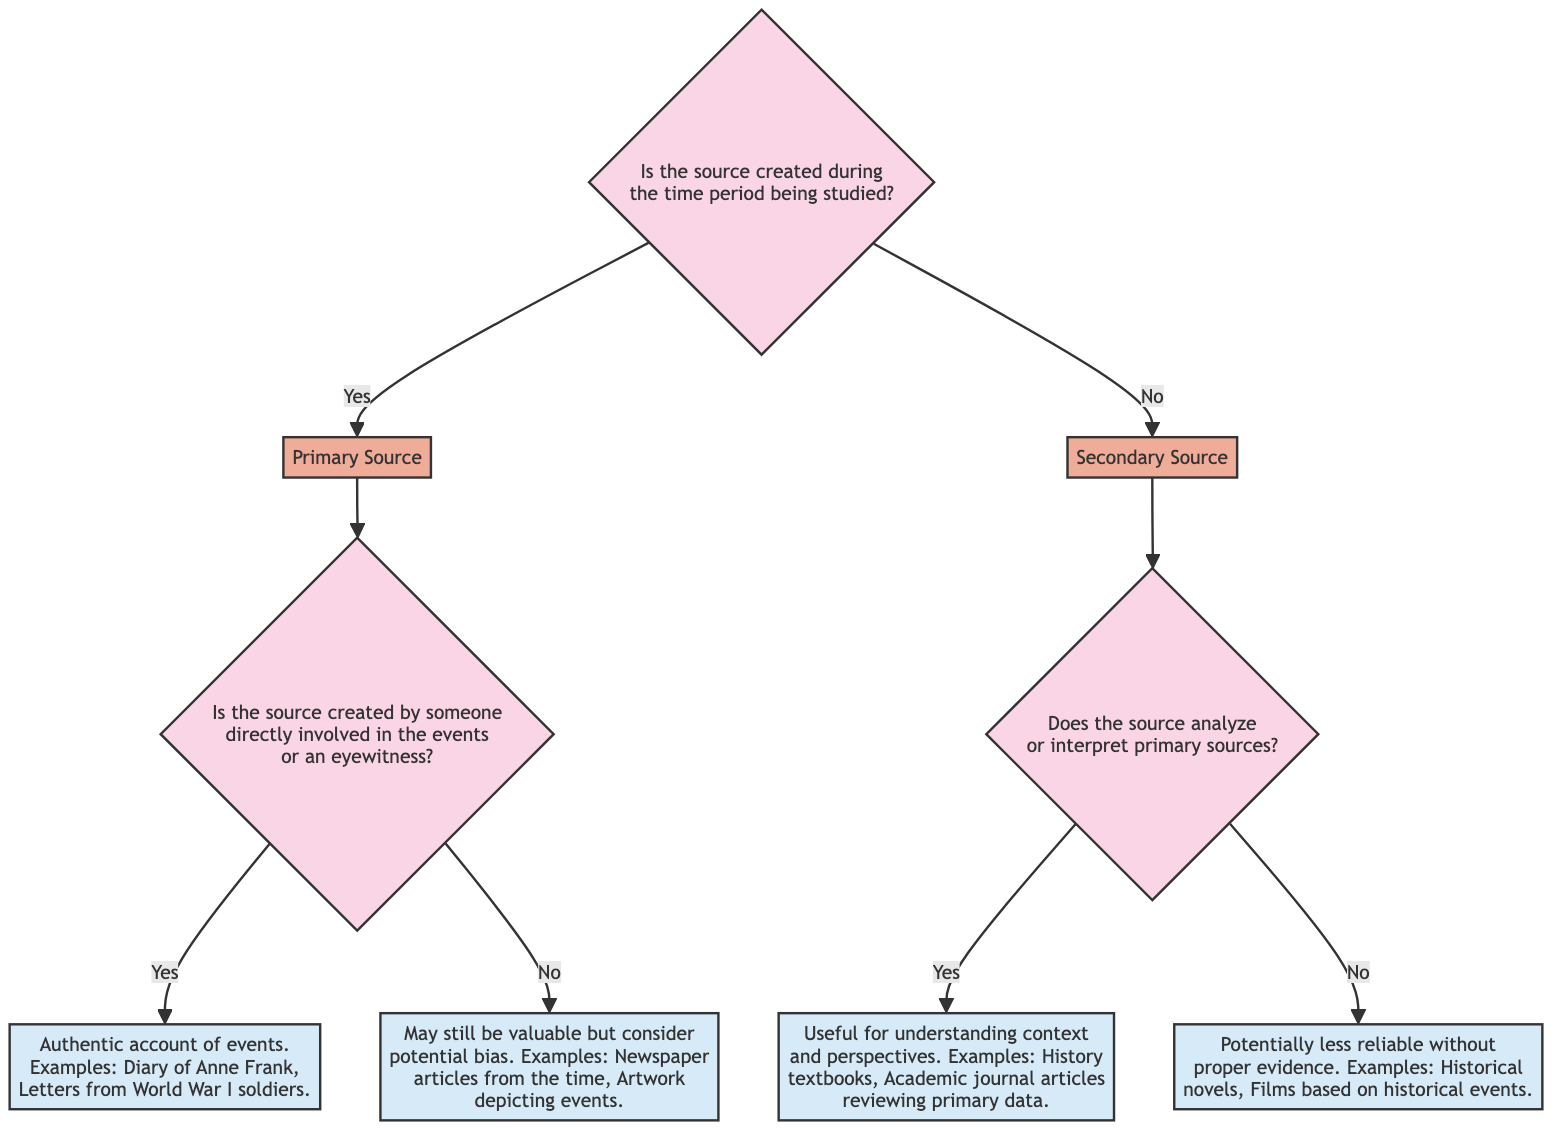What is the first question asked in the diagram? The first question asked in the diagram is "Is the source created during the time period being studied?" This is indicated at the top node of the decision tree.
Answer: Is the source created during the time period being studied? How many leaf nodes are there in total? The diagram has four leaf nodes: F, G, H, and I. These leaf nodes represent the final outcomes in the evaluation process.
Answer: 4 If the answer to the first question is "No," what is the next question? If the answer to the first question is "No," the next question is "Does the source analyze or interpret primary sources?" This is the question leading into the secondary source branch.
Answer: Does the source analyze or interpret primary sources? What is the result if the source is created by an eyewitness? If the source is created by someone directly involved in the events or an eyewitness, the result is an "Authentic account of events." This leaves us with examples such as "Diary of Anne Frank."
Answer: Authentic account of events What type of source is produced if the source was not created during the time period and does not analyze primary sources? If the source was not created during the time period and does not analyze primary sources, it is considered "Potentially less reliable without proper evidence." This is categorized as a secondary source.
Answer: Potentially less reliable without proper evidence What are the two categories of sources established by the first question? The two categories of sources established by the first question are Primary Source and Secondary Source. If the answer is "Yes," it leads to a primary source; if "No," it leads to a secondary source.
Answer: Primary Source and Secondary Source 